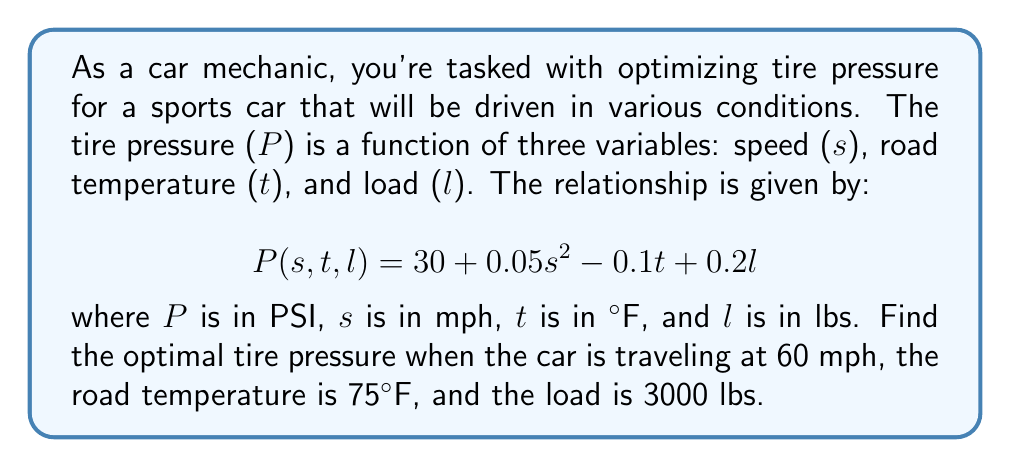Solve this math problem. To solve this problem, we'll use the given function and substitute the values for speed, temperature, and load:

1) We have the function:
   $$P(s,t,l) = 30 + 0.05s^2 - 0.1t + 0.2l$$

2) Given values:
   $s = 60$ mph
   $t = 75$ °F
   $l = 3000$ lbs

3) Substituting these values into the function:
   $$P(60,75,3000) = 30 + 0.05(60)^2 - 0.1(75) + 0.2(3000)$$

4) Let's calculate each term:
   - $30$ remains as is
   - $0.05(60)^2 = 0.05(3600) = 180$
   - $-0.1(75) = -7.5$
   - $0.2(3000) = 600$

5) Now, sum all the terms:
   $$P = 30 + 180 - 7.5 + 600 = 802.5$$

Therefore, the optimal tire pressure under these conditions is 802.5 PSI.
Answer: 802.5 PSI 